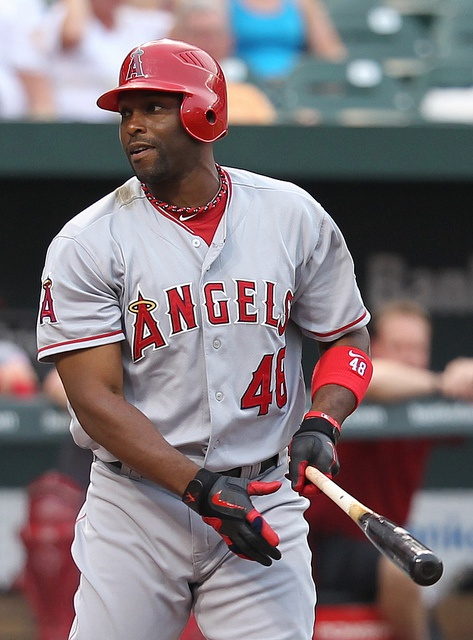Describe the objects in this image and their specific colors. I can see people in white, lightgray, darkgray, gray, and black tones, people in white, black, maroon, lightpink, and gray tones, baseball bat in white, black, gray, and darkgray tones, and people in white, lightpink, brown, lightgray, and darkgray tones in this image. 